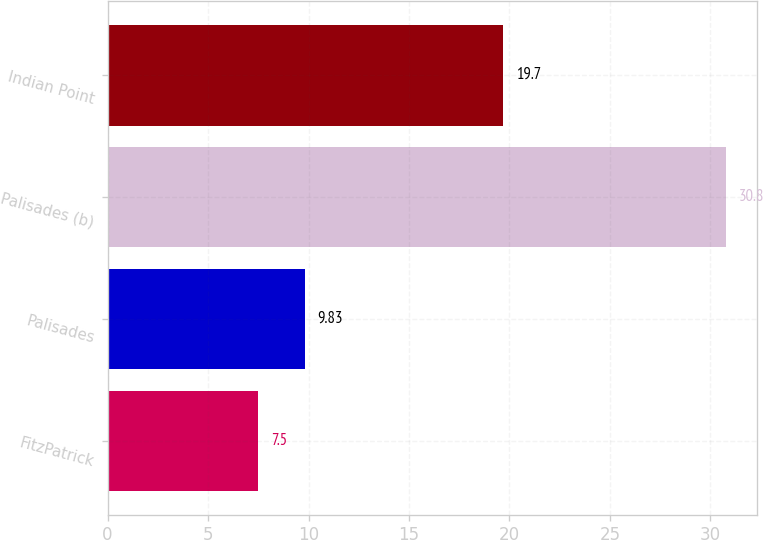Convert chart to OTSL. <chart><loc_0><loc_0><loc_500><loc_500><bar_chart><fcel>FitzPatrick<fcel>Palisades<fcel>Palisades (b)<fcel>Indian Point<nl><fcel>7.5<fcel>9.83<fcel>30.8<fcel>19.7<nl></chart> 